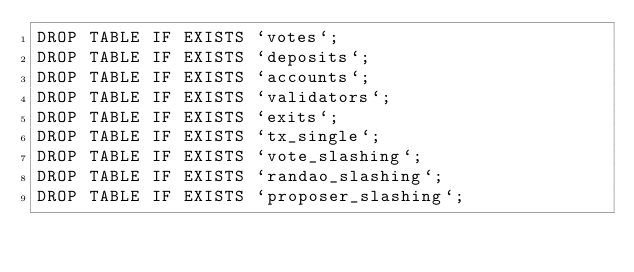<code> <loc_0><loc_0><loc_500><loc_500><_SQL_>DROP TABLE IF EXISTS `votes`;
DROP TABLE IF EXISTS `deposits`;
DROP TABLE IF EXISTS `accounts`;
DROP TABLE IF EXISTS `validators`;
DROP TABLE IF EXISTS `exits`;
DROP TABLE IF EXISTS `tx_single`;
DROP TABLE IF EXISTS `vote_slashing`;
DROP TABLE IF EXISTS `randao_slashing`;
DROP TABLE IF EXISTS `proposer_slashing`;</code> 